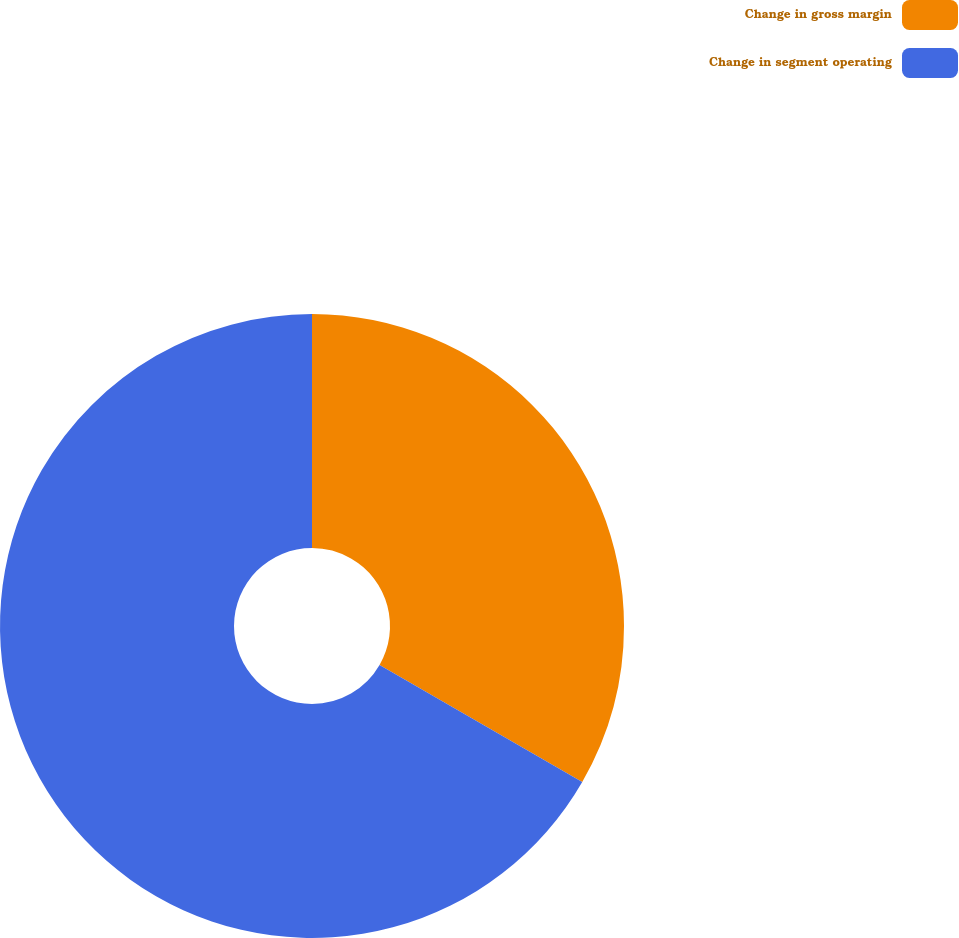Convert chart. <chart><loc_0><loc_0><loc_500><loc_500><pie_chart><fcel>Change in gross margin<fcel>Change in segment operating<nl><fcel>33.33%<fcel>66.67%<nl></chart> 